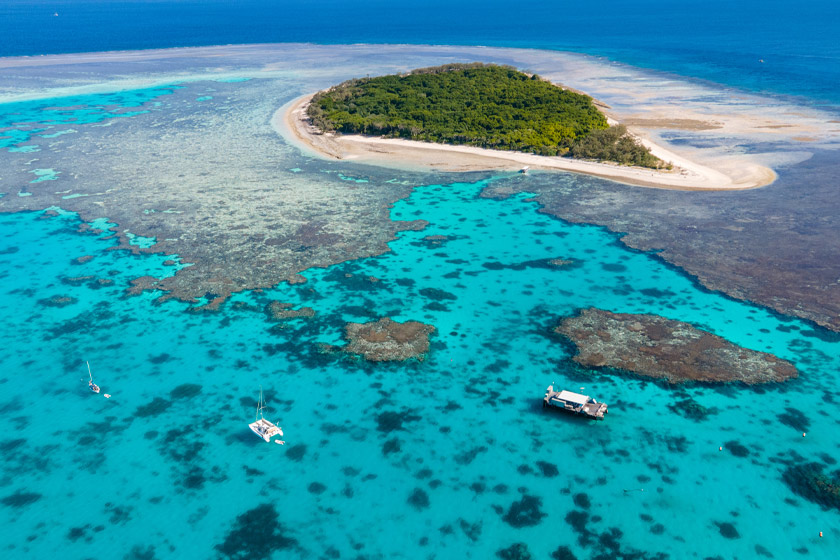What kinds of activities are typically carried out by tourists visiting locations like the one shown in the image? Tourists at the Great Barrier Reef often engage in snorkeling to observe the incredible variety of marine life and colorful coral. Diving trips are also popular, as they allow for a closer examination of the underwater landscapes and ecosystems. Other activities include glass-bottom boat tours, which offer a clear view of the underwater world without getting wet, and island day trips where visitors can relax on the beaches, hike through island trails, and enjoy picnics in pristine natural settings. 